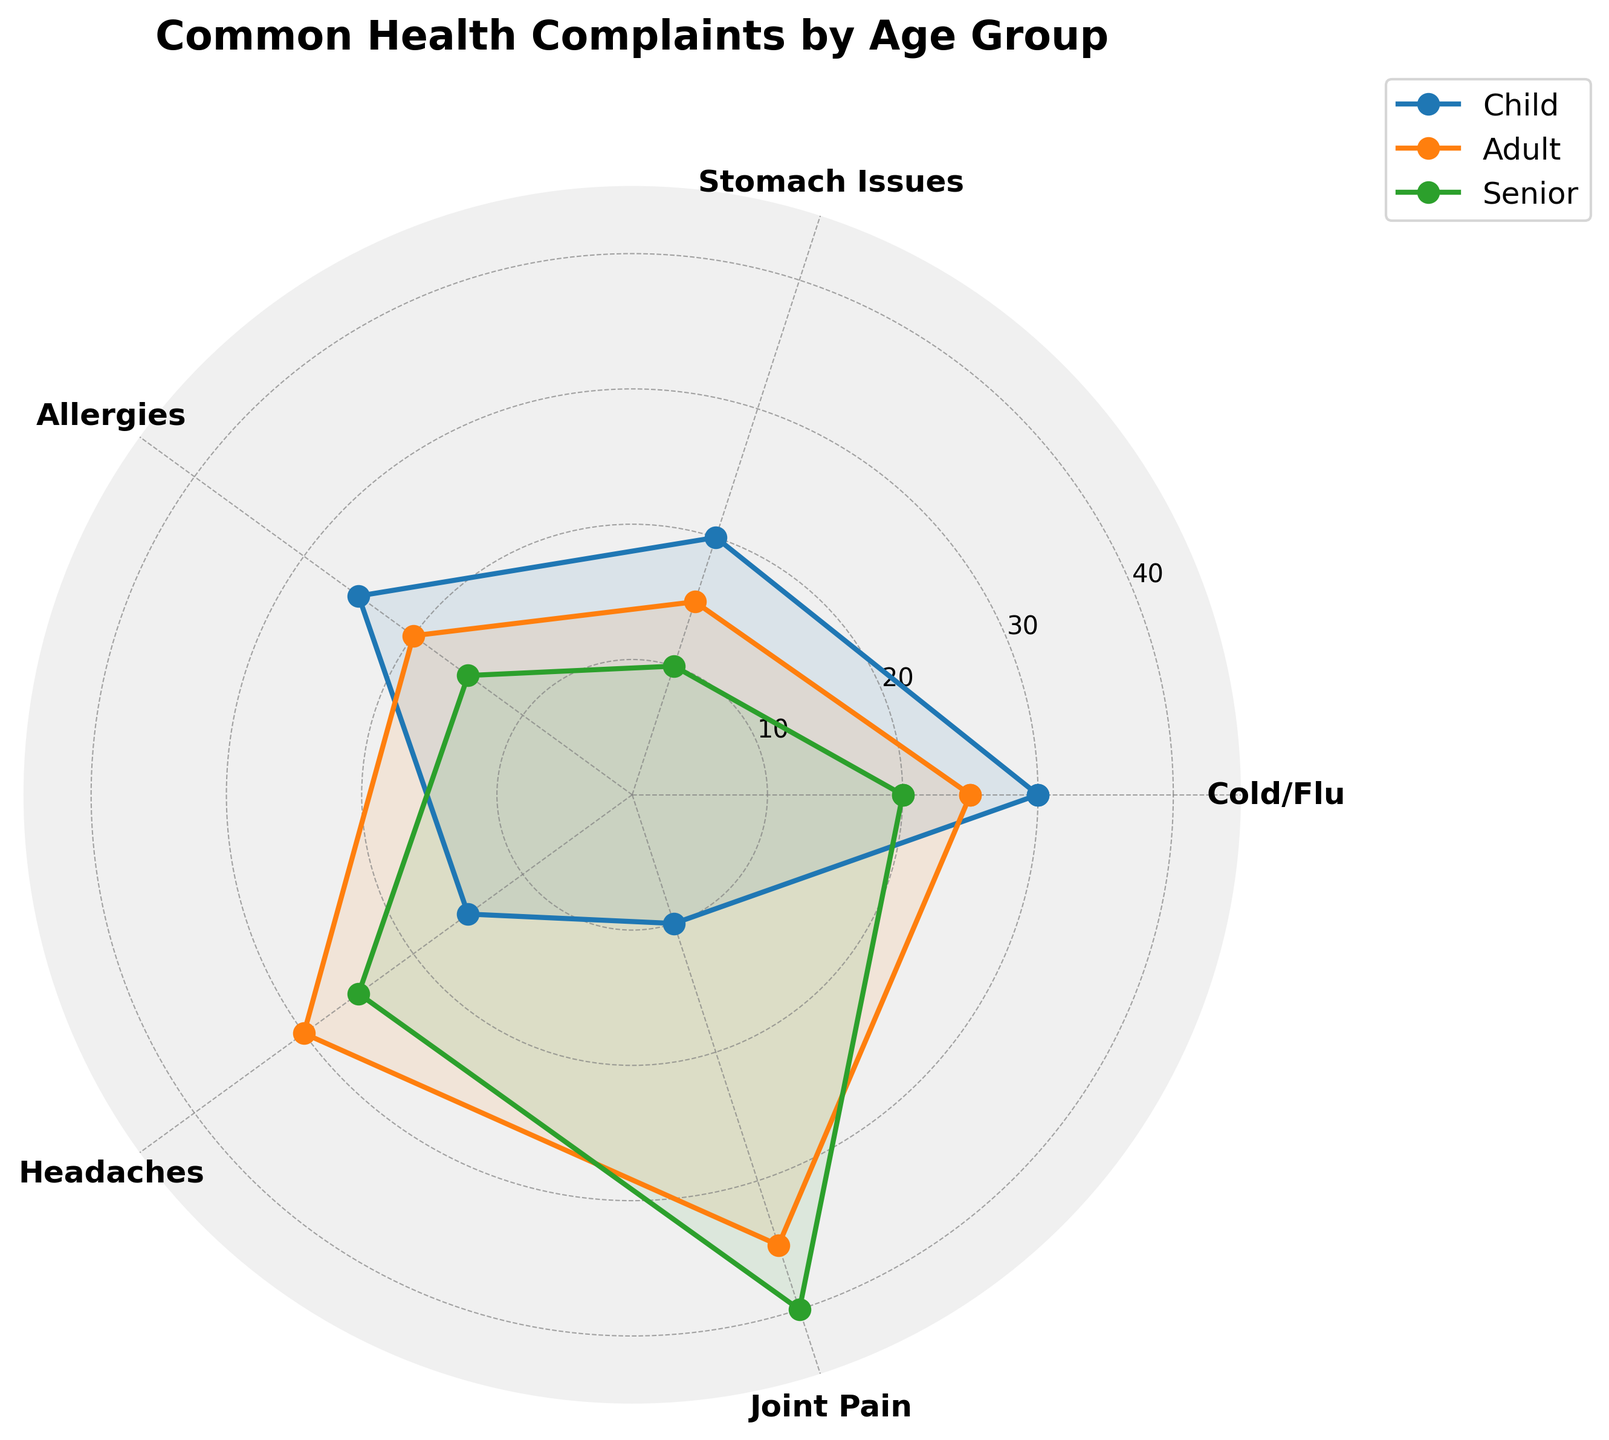Which age group has the highest frequency of headaches? Look at the plot where 'Headaches' align with the angle on the radar chart, and see which group's value goes furthest to the outer circle.
Answer: Senior What is the average frequency of joint pain complaints between the Adult and Senior groups? The values for joint pain for Adult and Senior are 35 and 40, respectively. Average = (35 + 40) / 2 = 37.5
Answer: 37.5 Which category has the smallest difference in values between the Adult and Child groups? Calculate the absolute differences between Adult and Child for each category: Cold/Flu (5), Stomach Issues (5), Allergies (5), Headaches (15), Joint Pain (25). Stomach Issues, Cold/Flu, and Allergies all have the smallest difference.
Answer: Cold/Flu, Stomach Issues, Allergies What is the average frequency of all health complaints for the Child age group? Sum the values for Cold/Flu (30), Stomach Issues (20), Allergies (25), Headaches (15), and Joint Pain (10). Average = (30 + 20 + 25 + 15 + 10) / 5 = 20
Answer: 20 Which health complaint has the greatest range across all age groups? Calculate the range (max - min) for each complaint: Cold/Flu (30-20=10), Stomach Issues (20-10=10), Allergies (25-15=10), Headaches (25-15=10), Joint Pain (40-10=30). Joint Pain has the greatest range.
Answer: Joint Pain Which age group has the lowest complaints for Stomach Issues? Look at Stomach Issues and identify the smallest value.
Answer: Senior Between Cold/Flu and Allergies, which complaint is more frequent among children? Compare the values for Cold/Flu (30) and Allergies (25) in the Child group. Cold/Flu is higher.
Answer: Cold/Flu What is the sum of complaints for Cold/Flu and Headaches in the Senior group? Add the values for Cold/Flu (20) and Headaches (25) in Seniors. Sum = 20 + 25 = 45
Answer: 45 Which age group has the most consistent (i.e., smallest range) health complaints? Calculate the range for each age group: Child (30-10 = 20), Adult (35-15 = 20), Senior (40-10 = 30). Both Child and Adult have a range of 20, which is the smallest range.
Answer: Child, Adult How do the complaints of Allergies compare between Adults and Seniors? Compare the values: Allergies for Adult (20) and Senior (15). Adults have a higher value.
Answer: Adults 